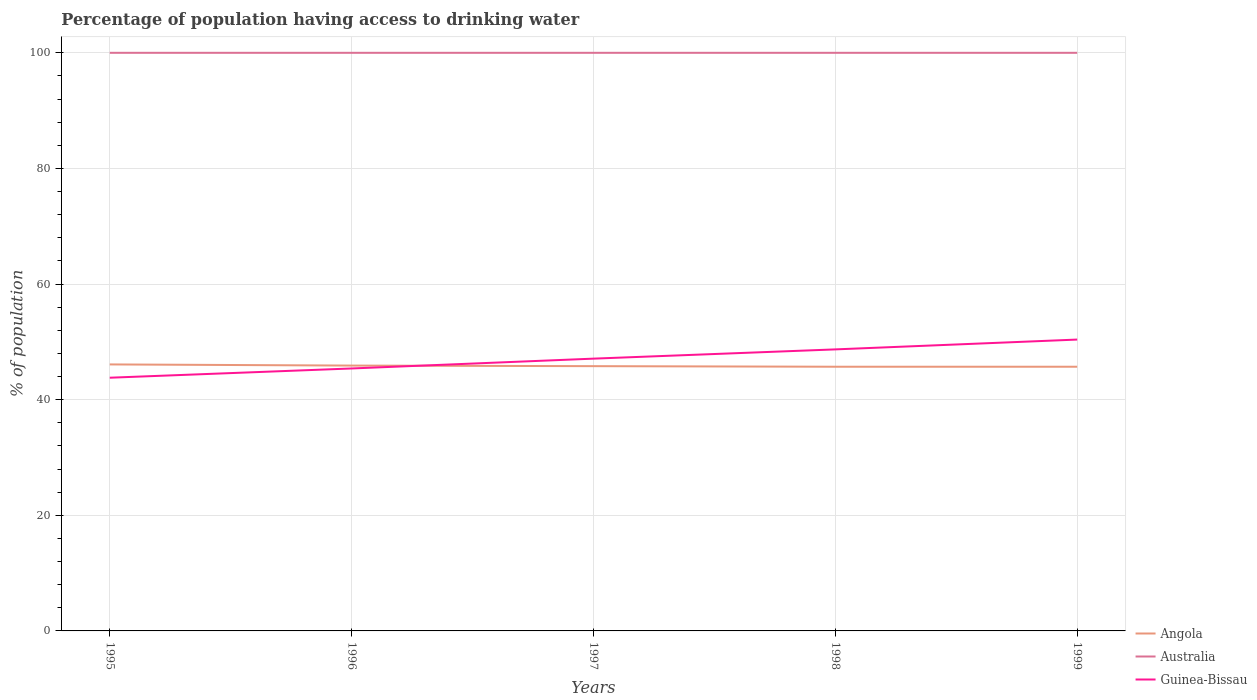Is the number of lines equal to the number of legend labels?
Ensure brevity in your answer.  Yes. Across all years, what is the maximum percentage of population having access to drinking water in Guinea-Bissau?
Offer a very short reply. 43.8. What is the total percentage of population having access to drinking water in Australia in the graph?
Your answer should be very brief. 0. What is the difference between the highest and the second highest percentage of population having access to drinking water in Angola?
Ensure brevity in your answer.  0.4. What is the difference between the highest and the lowest percentage of population having access to drinking water in Australia?
Provide a succinct answer. 0. Is the percentage of population having access to drinking water in Guinea-Bissau strictly greater than the percentage of population having access to drinking water in Australia over the years?
Give a very brief answer. Yes. How many lines are there?
Give a very brief answer. 3. Does the graph contain any zero values?
Provide a succinct answer. No. How are the legend labels stacked?
Make the answer very short. Vertical. What is the title of the graph?
Ensure brevity in your answer.  Percentage of population having access to drinking water. Does "Russian Federation" appear as one of the legend labels in the graph?
Offer a very short reply. No. What is the label or title of the X-axis?
Your answer should be very brief. Years. What is the label or title of the Y-axis?
Offer a very short reply. % of population. What is the % of population of Angola in 1995?
Keep it short and to the point. 46.1. What is the % of population of Australia in 1995?
Your answer should be very brief. 100. What is the % of population of Guinea-Bissau in 1995?
Your response must be concise. 43.8. What is the % of population of Angola in 1996?
Your answer should be very brief. 45.9. What is the % of population of Guinea-Bissau in 1996?
Provide a succinct answer. 45.4. What is the % of population of Angola in 1997?
Your response must be concise. 45.8. What is the % of population of Guinea-Bissau in 1997?
Your answer should be compact. 47.1. What is the % of population in Angola in 1998?
Your answer should be very brief. 45.7. What is the % of population in Australia in 1998?
Your response must be concise. 100. What is the % of population of Guinea-Bissau in 1998?
Offer a terse response. 48.7. What is the % of population in Angola in 1999?
Offer a very short reply. 45.7. What is the % of population in Guinea-Bissau in 1999?
Provide a short and direct response. 50.4. Across all years, what is the maximum % of population of Angola?
Keep it short and to the point. 46.1. Across all years, what is the maximum % of population in Guinea-Bissau?
Your answer should be compact. 50.4. Across all years, what is the minimum % of population in Angola?
Provide a short and direct response. 45.7. Across all years, what is the minimum % of population in Guinea-Bissau?
Your response must be concise. 43.8. What is the total % of population in Angola in the graph?
Give a very brief answer. 229.2. What is the total % of population of Guinea-Bissau in the graph?
Make the answer very short. 235.4. What is the difference between the % of population of Angola in 1995 and that in 1996?
Give a very brief answer. 0.2. What is the difference between the % of population of Australia in 1995 and that in 1996?
Offer a very short reply. 0. What is the difference between the % of population in Angola in 1995 and that in 1997?
Make the answer very short. 0.3. What is the difference between the % of population in Australia in 1995 and that in 1997?
Give a very brief answer. 0. What is the difference between the % of population of Australia in 1995 and that in 1998?
Your answer should be compact. 0. What is the difference between the % of population in Angola in 1995 and that in 1999?
Your response must be concise. 0.4. What is the difference between the % of population of Guinea-Bissau in 1995 and that in 1999?
Offer a terse response. -6.6. What is the difference between the % of population in Guinea-Bissau in 1996 and that in 1997?
Make the answer very short. -1.7. What is the difference between the % of population in Guinea-Bissau in 1996 and that in 1999?
Offer a terse response. -5. What is the difference between the % of population in Angola in 1997 and that in 1998?
Your answer should be compact. 0.1. What is the difference between the % of population in Australia in 1997 and that in 1999?
Provide a short and direct response. 0. What is the difference between the % of population in Guinea-Bissau in 1997 and that in 1999?
Make the answer very short. -3.3. What is the difference between the % of population in Angola in 1998 and that in 1999?
Provide a short and direct response. 0. What is the difference between the % of population in Guinea-Bissau in 1998 and that in 1999?
Provide a succinct answer. -1.7. What is the difference between the % of population of Angola in 1995 and the % of population of Australia in 1996?
Your response must be concise. -53.9. What is the difference between the % of population of Australia in 1995 and the % of population of Guinea-Bissau in 1996?
Offer a very short reply. 54.6. What is the difference between the % of population of Angola in 1995 and the % of population of Australia in 1997?
Give a very brief answer. -53.9. What is the difference between the % of population of Angola in 1995 and the % of population of Guinea-Bissau in 1997?
Offer a terse response. -1. What is the difference between the % of population of Australia in 1995 and the % of population of Guinea-Bissau in 1997?
Make the answer very short. 52.9. What is the difference between the % of population in Angola in 1995 and the % of population in Australia in 1998?
Your answer should be very brief. -53.9. What is the difference between the % of population in Angola in 1995 and the % of population in Guinea-Bissau in 1998?
Your answer should be compact. -2.6. What is the difference between the % of population in Australia in 1995 and the % of population in Guinea-Bissau in 1998?
Your answer should be very brief. 51.3. What is the difference between the % of population of Angola in 1995 and the % of population of Australia in 1999?
Provide a short and direct response. -53.9. What is the difference between the % of population in Angola in 1995 and the % of population in Guinea-Bissau in 1999?
Ensure brevity in your answer.  -4.3. What is the difference between the % of population in Australia in 1995 and the % of population in Guinea-Bissau in 1999?
Keep it short and to the point. 49.6. What is the difference between the % of population in Angola in 1996 and the % of population in Australia in 1997?
Offer a terse response. -54.1. What is the difference between the % of population in Angola in 1996 and the % of population in Guinea-Bissau in 1997?
Give a very brief answer. -1.2. What is the difference between the % of population of Australia in 1996 and the % of population of Guinea-Bissau in 1997?
Offer a very short reply. 52.9. What is the difference between the % of population of Angola in 1996 and the % of population of Australia in 1998?
Provide a short and direct response. -54.1. What is the difference between the % of population of Australia in 1996 and the % of population of Guinea-Bissau in 1998?
Your answer should be very brief. 51.3. What is the difference between the % of population of Angola in 1996 and the % of population of Australia in 1999?
Keep it short and to the point. -54.1. What is the difference between the % of population of Angola in 1996 and the % of population of Guinea-Bissau in 1999?
Your answer should be very brief. -4.5. What is the difference between the % of population of Australia in 1996 and the % of population of Guinea-Bissau in 1999?
Your answer should be compact. 49.6. What is the difference between the % of population in Angola in 1997 and the % of population in Australia in 1998?
Your response must be concise. -54.2. What is the difference between the % of population of Angola in 1997 and the % of population of Guinea-Bissau in 1998?
Provide a short and direct response. -2.9. What is the difference between the % of population of Australia in 1997 and the % of population of Guinea-Bissau in 1998?
Offer a very short reply. 51.3. What is the difference between the % of population in Angola in 1997 and the % of population in Australia in 1999?
Ensure brevity in your answer.  -54.2. What is the difference between the % of population of Angola in 1997 and the % of population of Guinea-Bissau in 1999?
Keep it short and to the point. -4.6. What is the difference between the % of population of Australia in 1997 and the % of population of Guinea-Bissau in 1999?
Make the answer very short. 49.6. What is the difference between the % of population of Angola in 1998 and the % of population of Australia in 1999?
Ensure brevity in your answer.  -54.3. What is the difference between the % of population in Australia in 1998 and the % of population in Guinea-Bissau in 1999?
Your answer should be compact. 49.6. What is the average % of population in Angola per year?
Your answer should be very brief. 45.84. What is the average % of population in Australia per year?
Your response must be concise. 100. What is the average % of population in Guinea-Bissau per year?
Offer a very short reply. 47.08. In the year 1995, what is the difference between the % of population in Angola and % of population in Australia?
Your answer should be compact. -53.9. In the year 1995, what is the difference between the % of population in Australia and % of population in Guinea-Bissau?
Keep it short and to the point. 56.2. In the year 1996, what is the difference between the % of population of Angola and % of population of Australia?
Make the answer very short. -54.1. In the year 1996, what is the difference between the % of population in Angola and % of population in Guinea-Bissau?
Give a very brief answer. 0.5. In the year 1996, what is the difference between the % of population of Australia and % of population of Guinea-Bissau?
Offer a very short reply. 54.6. In the year 1997, what is the difference between the % of population of Angola and % of population of Australia?
Your response must be concise. -54.2. In the year 1997, what is the difference between the % of population in Angola and % of population in Guinea-Bissau?
Offer a very short reply. -1.3. In the year 1997, what is the difference between the % of population in Australia and % of population in Guinea-Bissau?
Provide a short and direct response. 52.9. In the year 1998, what is the difference between the % of population of Angola and % of population of Australia?
Offer a very short reply. -54.3. In the year 1998, what is the difference between the % of population in Australia and % of population in Guinea-Bissau?
Your answer should be compact. 51.3. In the year 1999, what is the difference between the % of population in Angola and % of population in Australia?
Your answer should be very brief. -54.3. In the year 1999, what is the difference between the % of population in Angola and % of population in Guinea-Bissau?
Keep it short and to the point. -4.7. In the year 1999, what is the difference between the % of population in Australia and % of population in Guinea-Bissau?
Provide a succinct answer. 49.6. What is the ratio of the % of population of Australia in 1995 to that in 1996?
Offer a terse response. 1. What is the ratio of the % of population of Guinea-Bissau in 1995 to that in 1996?
Your answer should be very brief. 0.96. What is the ratio of the % of population in Angola in 1995 to that in 1997?
Your answer should be very brief. 1.01. What is the ratio of the % of population of Guinea-Bissau in 1995 to that in 1997?
Provide a short and direct response. 0.93. What is the ratio of the % of population of Angola in 1995 to that in 1998?
Your response must be concise. 1.01. What is the ratio of the % of population of Australia in 1995 to that in 1998?
Give a very brief answer. 1. What is the ratio of the % of population of Guinea-Bissau in 1995 to that in 1998?
Provide a short and direct response. 0.9. What is the ratio of the % of population in Angola in 1995 to that in 1999?
Make the answer very short. 1.01. What is the ratio of the % of population of Guinea-Bissau in 1995 to that in 1999?
Provide a succinct answer. 0.87. What is the ratio of the % of population in Guinea-Bissau in 1996 to that in 1997?
Offer a very short reply. 0.96. What is the ratio of the % of population in Angola in 1996 to that in 1998?
Offer a very short reply. 1. What is the ratio of the % of population in Australia in 1996 to that in 1998?
Your answer should be very brief. 1. What is the ratio of the % of population of Guinea-Bissau in 1996 to that in 1998?
Provide a short and direct response. 0.93. What is the ratio of the % of population of Guinea-Bissau in 1996 to that in 1999?
Ensure brevity in your answer.  0.9. What is the ratio of the % of population in Guinea-Bissau in 1997 to that in 1998?
Provide a short and direct response. 0.97. What is the ratio of the % of population in Australia in 1997 to that in 1999?
Ensure brevity in your answer.  1. What is the ratio of the % of population of Guinea-Bissau in 1997 to that in 1999?
Ensure brevity in your answer.  0.93. What is the ratio of the % of population of Angola in 1998 to that in 1999?
Keep it short and to the point. 1. What is the ratio of the % of population of Guinea-Bissau in 1998 to that in 1999?
Your answer should be compact. 0.97. What is the difference between the highest and the second highest % of population in Guinea-Bissau?
Provide a short and direct response. 1.7. What is the difference between the highest and the lowest % of population in Angola?
Offer a very short reply. 0.4. What is the difference between the highest and the lowest % of population in Guinea-Bissau?
Your response must be concise. 6.6. 